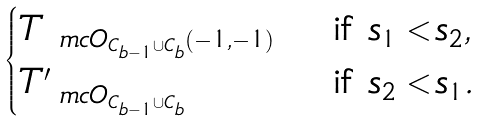<formula> <loc_0><loc_0><loc_500><loc_500>\begin{cases} T _ { \ m c { O } _ { C _ { b - 1 } \cup C _ { b } } ( - 1 , - 1 ) } & \text { if } s _ { 1 } < s _ { 2 } , \\ T ^ { \prime } _ { \ m c { O } _ { C _ { b - 1 } \cup C _ { b } } } & \text { if } s _ { 2 } < s _ { 1 } . \end{cases}</formula> 